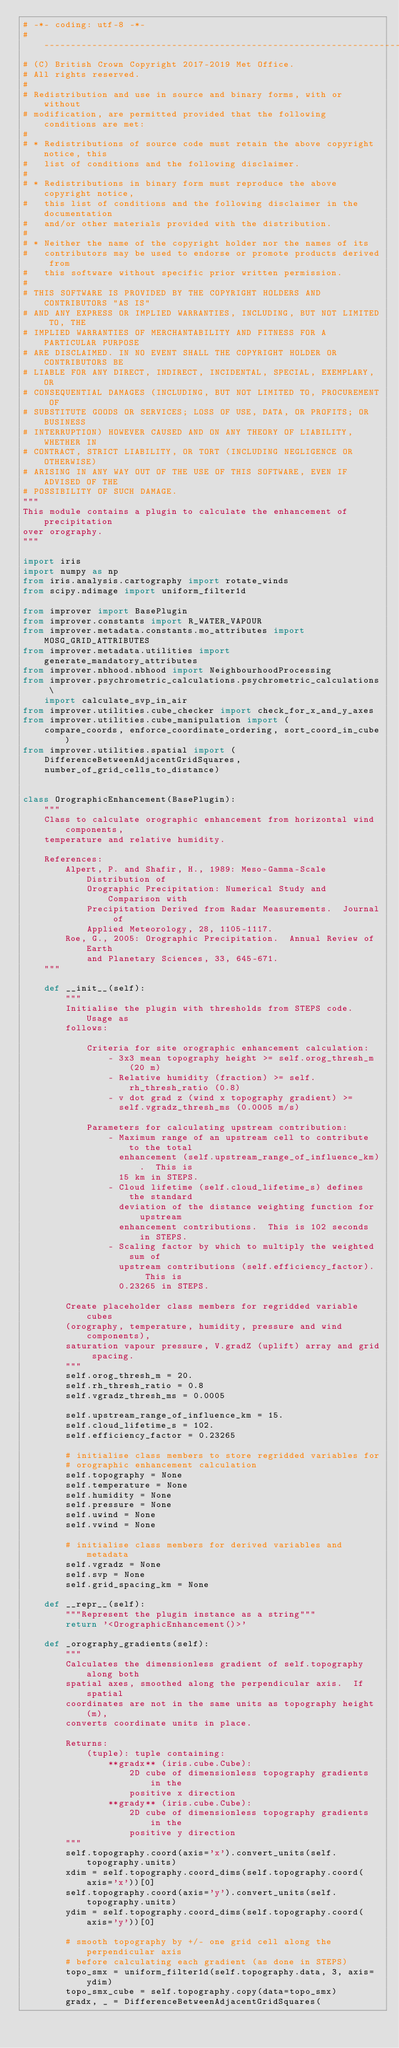<code> <loc_0><loc_0><loc_500><loc_500><_Python_># -*- coding: utf-8 -*-
# -----------------------------------------------------------------------------
# (C) British Crown Copyright 2017-2019 Met Office.
# All rights reserved.
#
# Redistribution and use in source and binary forms, with or without
# modification, are permitted provided that the following conditions are met:
#
# * Redistributions of source code must retain the above copyright notice, this
#   list of conditions and the following disclaimer.
#
# * Redistributions in binary form must reproduce the above copyright notice,
#   this list of conditions and the following disclaimer in the documentation
#   and/or other materials provided with the distribution.
#
# * Neither the name of the copyright holder nor the names of its
#   contributors may be used to endorse or promote products derived from
#   this software without specific prior written permission.
#
# THIS SOFTWARE IS PROVIDED BY THE COPYRIGHT HOLDERS AND CONTRIBUTORS "AS IS"
# AND ANY EXPRESS OR IMPLIED WARRANTIES, INCLUDING, BUT NOT LIMITED TO, THE
# IMPLIED WARRANTIES OF MERCHANTABILITY AND FITNESS FOR A PARTICULAR PURPOSE
# ARE DISCLAIMED. IN NO EVENT SHALL THE COPYRIGHT HOLDER OR CONTRIBUTORS BE
# LIABLE FOR ANY DIRECT, INDIRECT, INCIDENTAL, SPECIAL, EXEMPLARY, OR
# CONSEQUENTIAL DAMAGES (INCLUDING, BUT NOT LIMITED TO, PROCUREMENT OF
# SUBSTITUTE GOODS OR SERVICES; LOSS OF USE, DATA, OR PROFITS; OR BUSINESS
# INTERRUPTION) HOWEVER CAUSED AND ON ANY THEORY OF LIABILITY, WHETHER IN
# CONTRACT, STRICT LIABILITY, OR TORT (INCLUDING NEGLIGENCE OR OTHERWISE)
# ARISING IN ANY WAY OUT OF THE USE OF THIS SOFTWARE, EVEN IF ADVISED OF THE
# POSSIBILITY OF SUCH DAMAGE.
"""
This module contains a plugin to calculate the enhancement of precipitation
over orography.
"""

import iris
import numpy as np
from iris.analysis.cartography import rotate_winds
from scipy.ndimage import uniform_filter1d

from improver import BasePlugin
from improver.constants import R_WATER_VAPOUR
from improver.metadata.constants.mo_attributes import MOSG_GRID_ATTRIBUTES
from improver.metadata.utilities import generate_mandatory_attributes
from improver.nbhood.nbhood import NeighbourhoodProcessing
from improver.psychrometric_calculations.psychrometric_calculations \
    import calculate_svp_in_air
from improver.utilities.cube_checker import check_for_x_and_y_axes
from improver.utilities.cube_manipulation import (
    compare_coords, enforce_coordinate_ordering, sort_coord_in_cube)
from improver.utilities.spatial import (
    DifferenceBetweenAdjacentGridSquares,
    number_of_grid_cells_to_distance)


class OrographicEnhancement(BasePlugin):
    """
    Class to calculate orographic enhancement from horizontal wind components,
    temperature and relative humidity.

    References:
        Alpert, P. and Shafir, H., 1989: Meso-Gamma-Scale Distribution of
            Orographic Precipitation: Numerical Study and Comparison with
            Precipitation Derived from Radar Measurements.  Journal of
            Applied Meteorology, 28, 1105-1117.
        Roe, G., 2005: Orographic Precipitation.  Annual Review of Earth
            and Planetary Sciences, 33, 645-671.
    """

    def __init__(self):
        """
        Initialise the plugin with thresholds from STEPS code.  Usage as
        follows:

            Criteria for site orographic enhancement calculation:
                - 3x3 mean topography height >= self.orog_thresh_m (20 m)
                - Relative humidity (fraction) >= self.rh_thresh_ratio (0.8)
                - v dot grad z (wind x topography gradient) >=
                  self.vgradz_thresh_ms (0.0005 m/s)

            Parameters for calculating upstream contribution:
                - Maximum range of an upstream cell to contribute to the total
                  enhancement (self.upstream_range_of_influence_km).  This is
                  15 km in STEPS.
                - Cloud lifetime (self.cloud_lifetime_s) defines the standard
                  deviation of the distance weighting function for upstream
                  enhancement contributions.  This is 102 seconds in STEPS.
                - Scaling factor by which to multiply the weighted sum of
                  upstream contributions (self.efficiency_factor).  This is
                  0.23265 in STEPS.

        Create placeholder class members for regridded variable cubes
        (orography, temperature, humidity, pressure and wind components),
        saturation vapour pressure, V.gradZ (uplift) array and grid spacing.
        """
        self.orog_thresh_m = 20.
        self.rh_thresh_ratio = 0.8
        self.vgradz_thresh_ms = 0.0005

        self.upstream_range_of_influence_km = 15.
        self.cloud_lifetime_s = 102.
        self.efficiency_factor = 0.23265

        # initialise class members to store regridded variables for
        # orographic enhancement calculation
        self.topography = None
        self.temperature = None
        self.humidity = None
        self.pressure = None
        self.uwind = None
        self.vwind = None

        # initialise class members for derived variables and metadata
        self.vgradz = None
        self.svp = None
        self.grid_spacing_km = None

    def __repr__(self):
        """Represent the plugin instance as a string"""
        return '<OrographicEnhancement()>'

    def _orography_gradients(self):
        """
        Calculates the dimensionless gradient of self.topography along both
        spatial axes, smoothed along the perpendicular axis.  If spatial
        coordinates are not in the same units as topography height (m),
        converts coordinate units in place.

        Returns:
            (tuple): tuple containing:
                **gradx** (iris.cube.Cube):
                    2D cube of dimensionless topography gradients in the
                    positive x direction
                **grady** (iris.cube.Cube):
                    2D cube of dimensionless topography gradients in the
                    positive y direction
        """
        self.topography.coord(axis='x').convert_units(self.topography.units)
        xdim = self.topography.coord_dims(self.topography.coord(axis='x'))[0]
        self.topography.coord(axis='y').convert_units(self.topography.units)
        ydim = self.topography.coord_dims(self.topography.coord(axis='y'))[0]

        # smooth topography by +/- one grid cell along the perpendicular axis
        # before calculating each gradient (as done in STEPS)
        topo_smx = uniform_filter1d(self.topography.data, 3, axis=ydim)
        topo_smx_cube = self.topography.copy(data=topo_smx)
        gradx, _ = DifferenceBetweenAdjacentGridSquares(</code> 